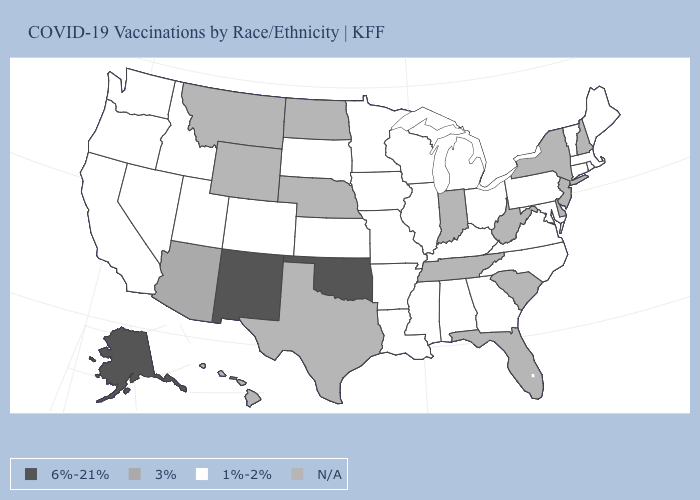Name the states that have a value in the range 1%-2%?
Write a very short answer. Alabama, Arkansas, California, Colorado, Connecticut, Georgia, Idaho, Illinois, Iowa, Kansas, Kentucky, Louisiana, Maine, Maryland, Massachusetts, Michigan, Minnesota, Mississippi, Missouri, Nevada, North Carolina, Ohio, Oregon, Pennsylvania, Rhode Island, South Dakota, Utah, Vermont, Virginia, Washington, Wisconsin. Does Idaho have the lowest value in the West?
Concise answer only. Yes. What is the value of Ohio?
Quick response, please. 1%-2%. What is the lowest value in the MidWest?
Write a very short answer. 1%-2%. What is the value of Colorado?
Give a very brief answer. 1%-2%. Name the states that have a value in the range 1%-2%?
Write a very short answer. Alabama, Arkansas, California, Colorado, Connecticut, Georgia, Idaho, Illinois, Iowa, Kansas, Kentucky, Louisiana, Maine, Maryland, Massachusetts, Michigan, Minnesota, Mississippi, Missouri, Nevada, North Carolina, Ohio, Oregon, Pennsylvania, Rhode Island, South Dakota, Utah, Vermont, Virginia, Washington, Wisconsin. Among the states that border Texas , does New Mexico have the highest value?
Keep it brief. Yes. What is the value of Louisiana?
Give a very brief answer. 1%-2%. What is the value of Oregon?
Concise answer only. 1%-2%. Name the states that have a value in the range 3%?
Keep it brief. Arizona. What is the lowest value in the Northeast?
Be succinct. 1%-2%. Does the map have missing data?
Keep it brief. Yes. 